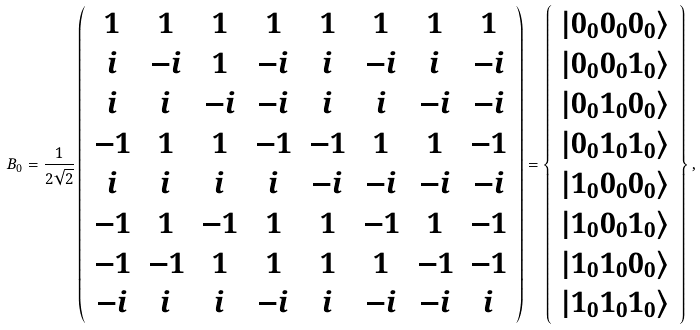<formula> <loc_0><loc_0><loc_500><loc_500>B _ { 0 } = \frac { 1 } { 2 \sqrt { 2 } } \left ( \begin{array} { c c c c c c c c } 1 & 1 & 1 & 1 & 1 & 1 & 1 & 1 \\ i & - i & 1 & - i & i & - i & i & - i \\ i & i & - i & - i & i & i & - i & - i \\ - 1 & 1 & 1 & - 1 & - 1 & 1 & 1 & - 1 \\ i & i & i & i & - i & - i & - i & - i \\ - 1 & 1 & - 1 & 1 & 1 & - 1 & 1 & - 1 \\ - 1 & - 1 & 1 & 1 & 1 & 1 & - 1 & - 1 \\ - i & i & i & - i & i & - i & - i & i \end{array} \right ) = \left \{ \begin{array} { c } | 0 _ { 0 } 0 _ { 0 } 0 _ { 0 } \rangle \\ | 0 _ { 0 } 0 _ { 0 } 1 _ { 0 } \rangle \\ | 0 _ { 0 } 1 _ { 0 } 0 _ { 0 } \rangle \\ | 0 _ { 0 } 1 _ { 0 } 1 _ { 0 } \rangle \\ | 1 _ { 0 } 0 _ { 0 } 0 _ { 0 } \rangle \\ | 1 _ { 0 } 0 _ { 0 } 1 _ { 0 } \rangle \\ | 1 _ { 0 } 1 _ { 0 } 0 _ { 0 } \rangle \\ | 1 _ { 0 } 1 _ { 0 } 1 _ { 0 } \rangle \end{array} \right \} ,</formula> 